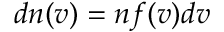Convert formula to latex. <formula><loc_0><loc_0><loc_500><loc_500>d n ( v ) = n f ( v ) d v</formula> 